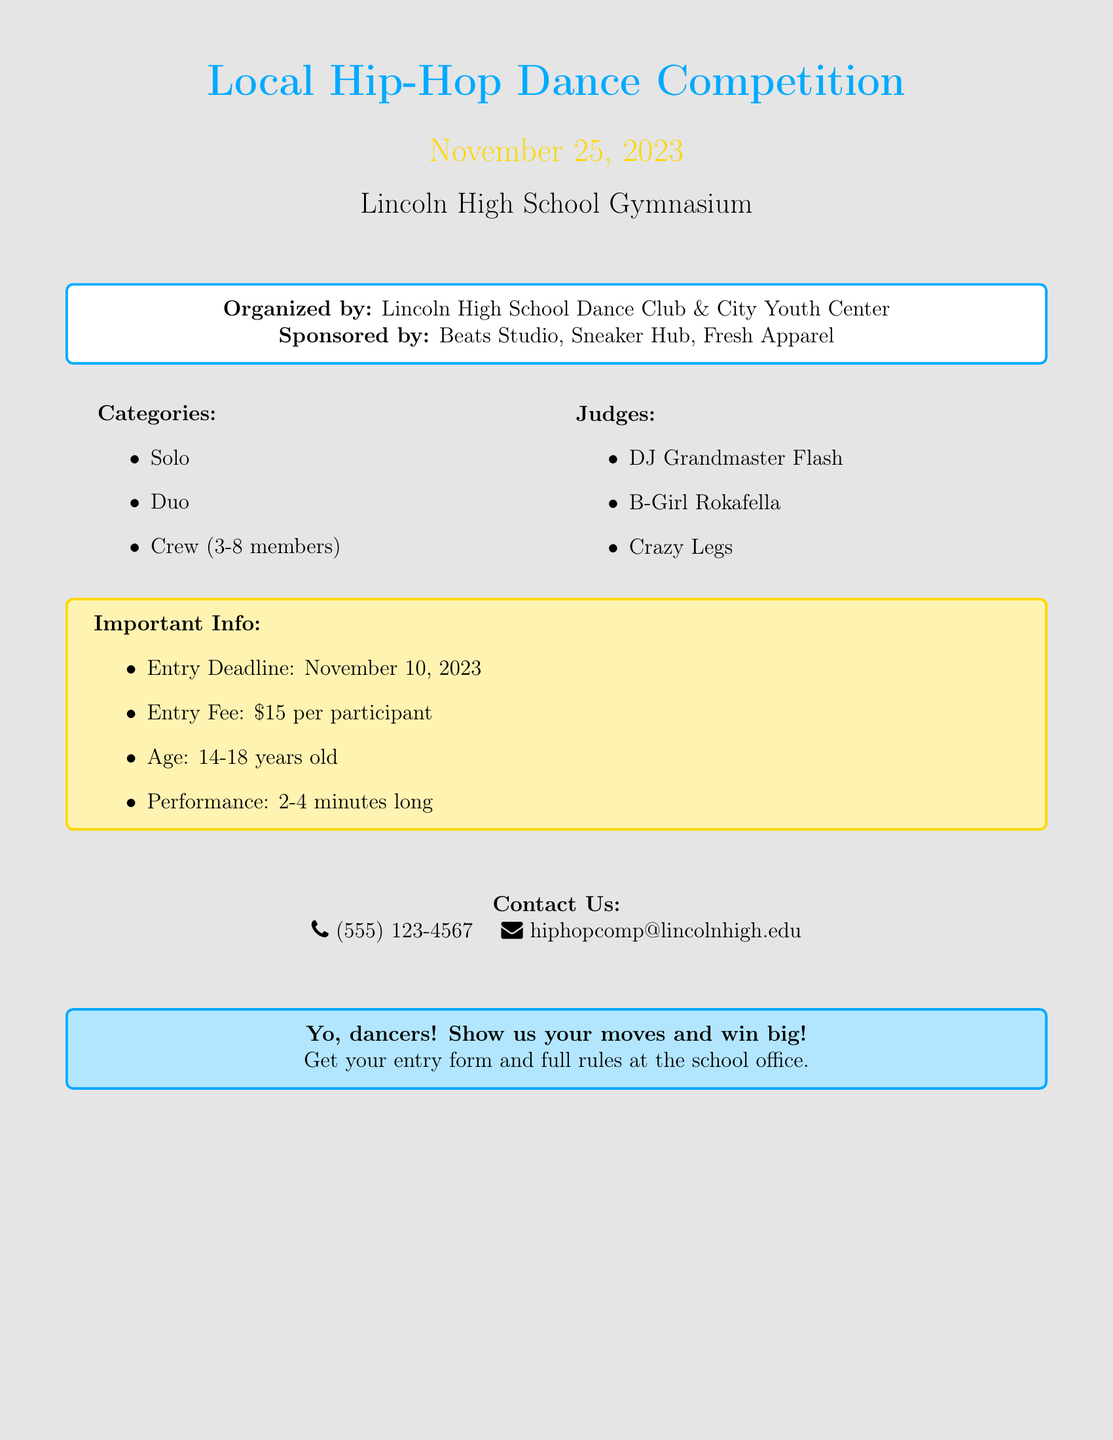What is the date of the competition? The date of the competition is mentioned clearly in the document.
Answer: November 25, 2023 What is the location of the event? The location is given in the document, specifying where the competition will take place.
Answer: Lincoln High School Gymnasium Who are the judges for the competition? The judges are clearly listed in the document, providing specific names associated with the hip-hop scene.
Answer: DJ Grandmaster Flash, B-Girl Rokafella, Crazy Legs What is the entry fee? The document specifies the cost required to enter the competition.
Answer: $15 per participant What are the age requirements to participate? The age requirements are outlined in the competition details within the document.
Answer: 14-18 years old How long should performances last? The performance duration is stated in the important information section of the document.
Answer: 2-4 minutes long When is the entry deadline? The entry deadline is noted clearly, indicating the last date to submit entries.
Answer: November 10, 2023 What categories can participants compete in? The document provides a list of categories for the competition, specifying different formats.
Answer: Solo, Duo, Crew (3-8 members) What should participants do to get entry forms? The document summarizes steps for acquiring entry forms, informing about actions to take.
Answer: Get your entry form and full rules at the school office 